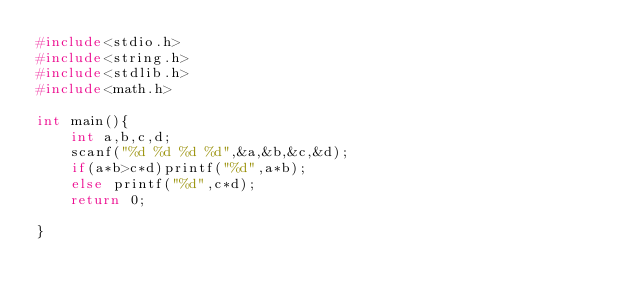Convert code to text. <code><loc_0><loc_0><loc_500><loc_500><_C_>#include<stdio.h>
#include<string.h>
#include<stdlib.h>
#include<math.h>

int main(){
    int a,b,c,d;
    scanf("%d %d %d %d",&a,&b,&c,&d);
    if(a*b>c*d)printf("%d",a*b);
    else printf("%d",c*d);
    return 0;
    
}</code> 